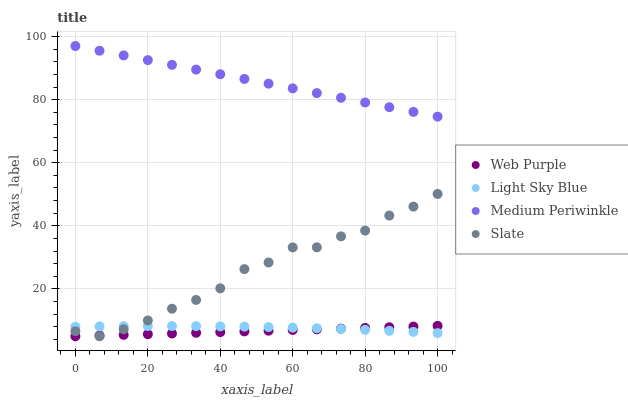Does Web Purple have the minimum area under the curve?
Answer yes or no. Yes. Does Medium Periwinkle have the maximum area under the curve?
Answer yes or no. Yes. Does Light Sky Blue have the minimum area under the curve?
Answer yes or no. No. Does Light Sky Blue have the maximum area under the curve?
Answer yes or no. No. Is Web Purple the smoothest?
Answer yes or no. Yes. Is Slate the roughest?
Answer yes or no. Yes. Is Light Sky Blue the smoothest?
Answer yes or no. No. Is Light Sky Blue the roughest?
Answer yes or no. No. Does Web Purple have the lowest value?
Answer yes or no. Yes. Does Light Sky Blue have the lowest value?
Answer yes or no. No. Does Medium Periwinkle have the highest value?
Answer yes or no. Yes. Does Light Sky Blue have the highest value?
Answer yes or no. No. Is Web Purple less than Medium Periwinkle?
Answer yes or no. Yes. Is Medium Periwinkle greater than Web Purple?
Answer yes or no. Yes. Does Web Purple intersect Slate?
Answer yes or no. Yes. Is Web Purple less than Slate?
Answer yes or no. No. Is Web Purple greater than Slate?
Answer yes or no. No. Does Web Purple intersect Medium Periwinkle?
Answer yes or no. No. 